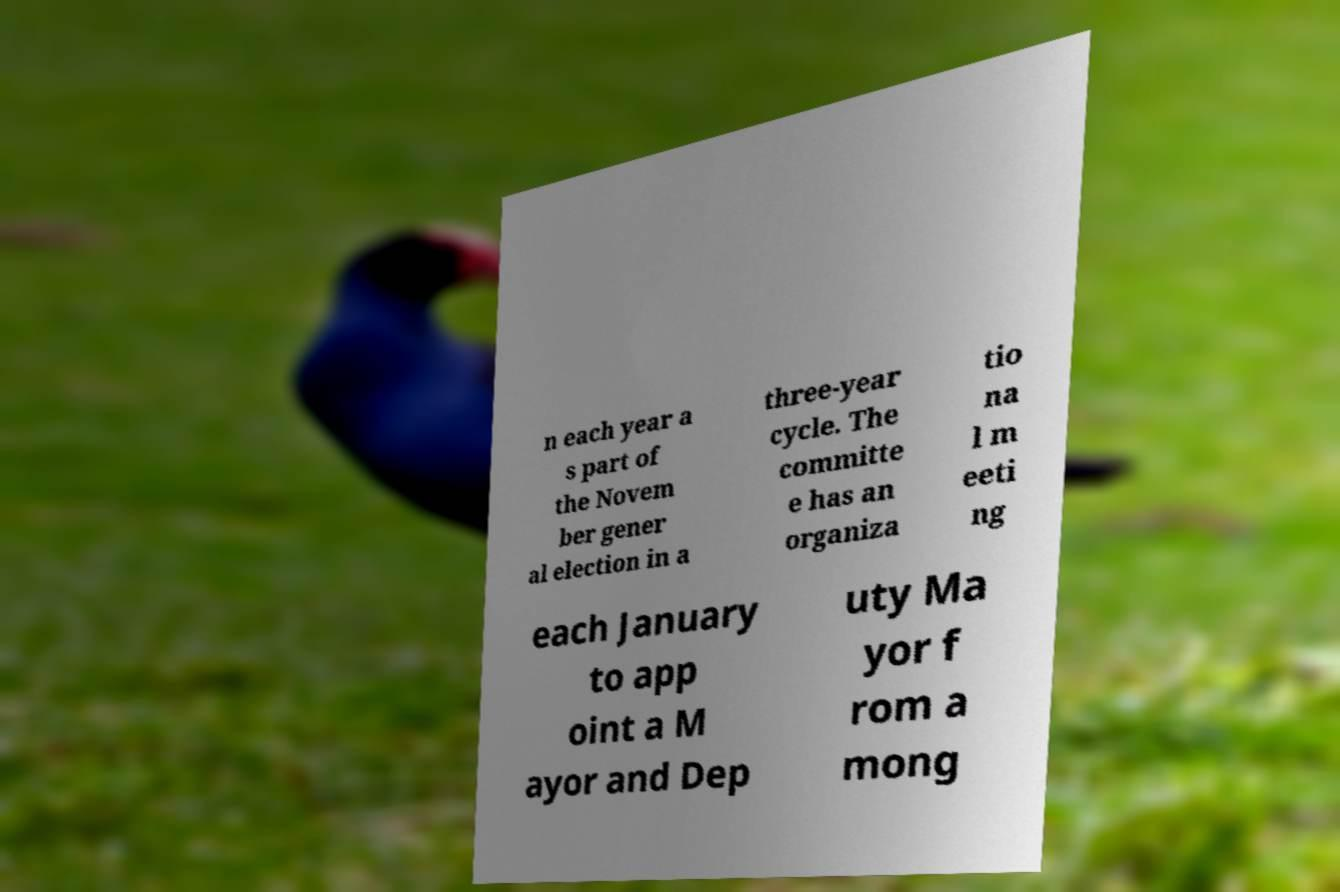There's text embedded in this image that I need extracted. Can you transcribe it verbatim? n each year a s part of the Novem ber gener al election in a three-year cycle. The committe e has an organiza tio na l m eeti ng each January to app oint a M ayor and Dep uty Ma yor f rom a mong 